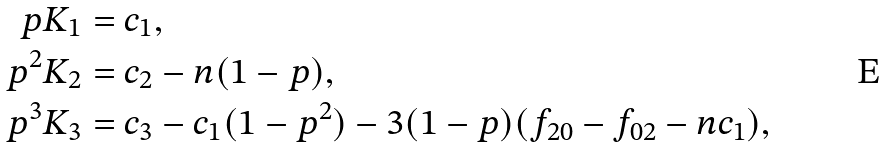Convert formula to latex. <formula><loc_0><loc_0><loc_500><loc_500>p K _ { 1 } & = c _ { 1 } , \\ p ^ { 2 } K _ { 2 } & = c _ { 2 } - n ( 1 - p ) , \\ p ^ { 3 } K _ { 3 } & = c _ { 3 } - c _ { 1 } ( 1 - p ^ { 2 } ) - 3 ( 1 - p ) ( f _ { 2 0 } - f _ { 0 2 } - n c _ { 1 } ) ,</formula> 